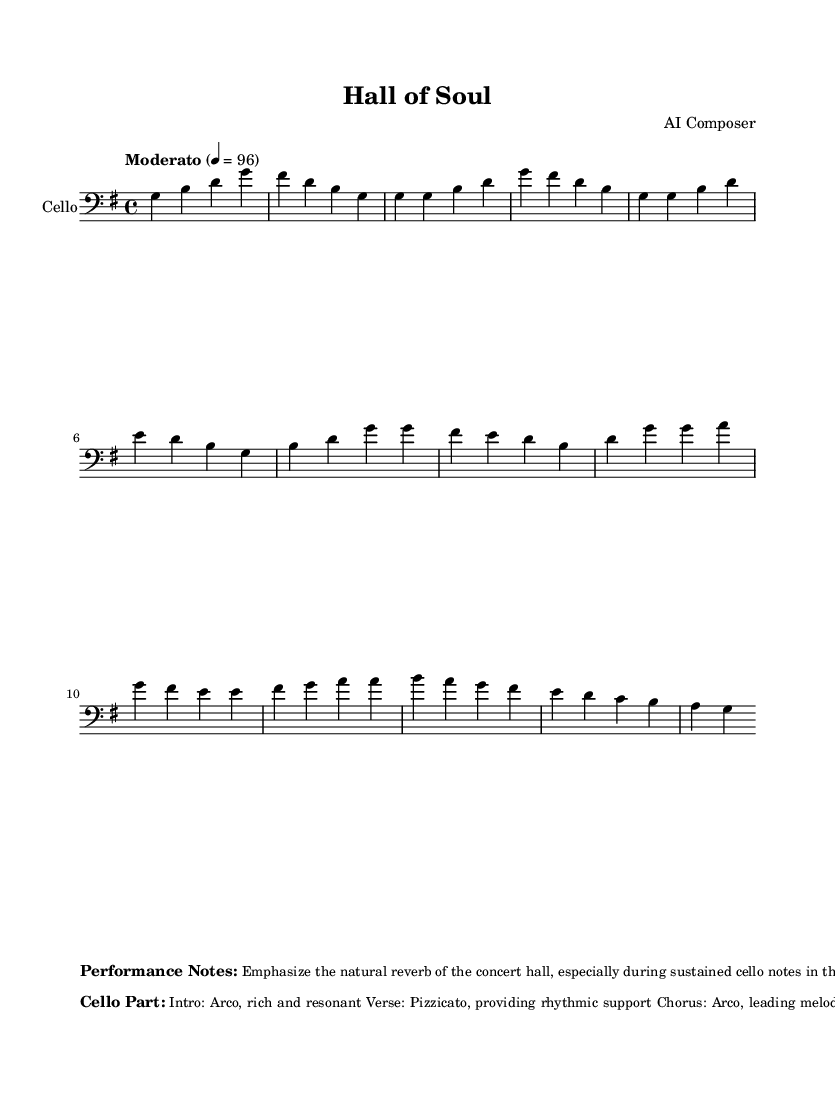What is the key signature of this music? The key signature is G major, which has one sharp (F#).
Answer: G major What is the time signature of the piece? The time signature is 4/4, indicating four beats per measure.
Answer: 4/4 What is the tempo marking for the piece? The tempo marking indicates a "Moderato" tempo, which is generally moderate in speed.
Answer: Moderato How many measures are in the intro section? The intro section consists of two measures, as indicated by the grouping of notes at the beginning.
Answer: 2 What technique is used for the cello part during the verse? The cello part employs pizzicato technique during the verse, which is noted in the performance instructions.
Answer: Pizzicato How does the bridge section contribute to the overall dynamic of the piece? The bridge section builds tension through the use of tremolo as a technique, which heightens the emotional impact before returning to the chorus.
Answer: Builds tension What is emphasized in the performance notes and how should it be executed? The performance notes emphasize showcasing the natural reverb of the concert hall during sustained notes, with longer decay times noted for the audience to appreciate the acoustics.
Answer: Natural reverb 